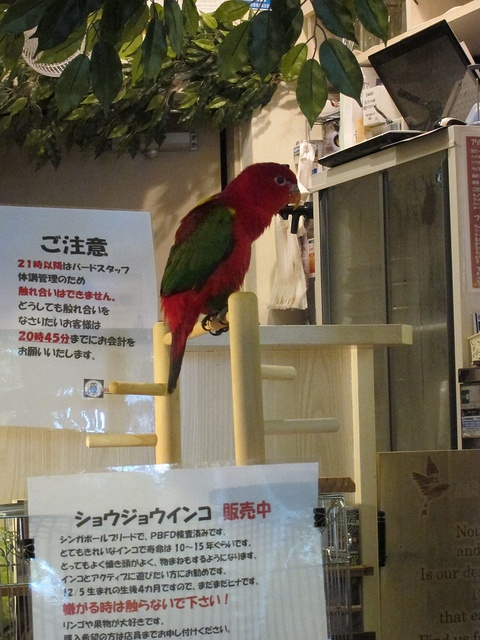Describe the objects in this image and their specific colors. I can see a bird in black, maroon, and brown tones in this image. 